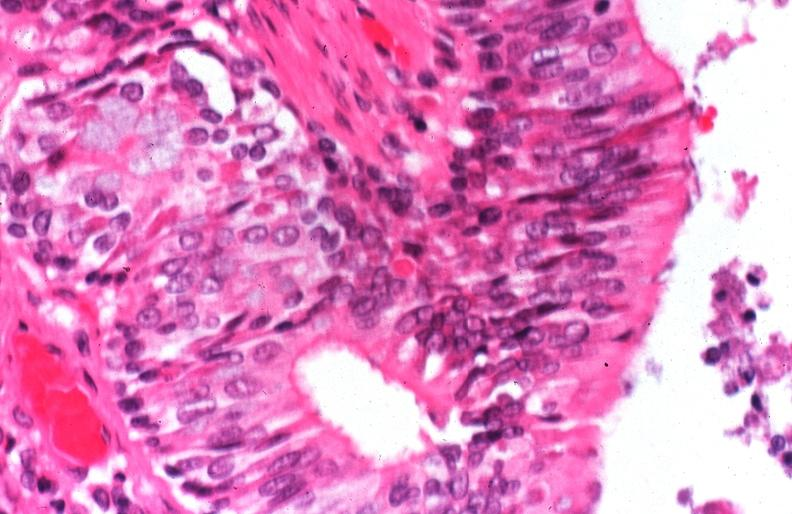what does this image show?
Answer the question using a single word or phrase. Lung 